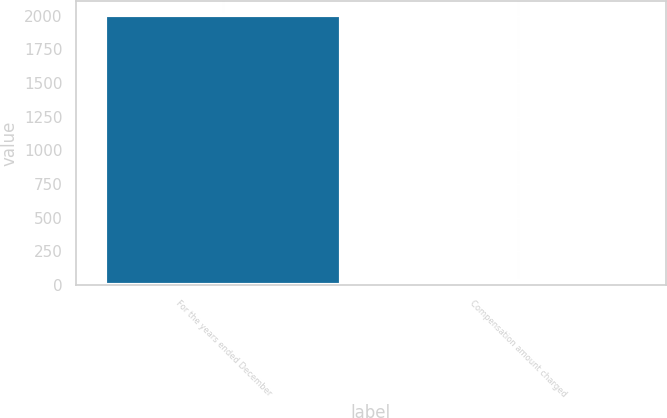Convert chart to OTSL. <chart><loc_0><loc_0><loc_500><loc_500><bar_chart><fcel>For the years ended December<fcel>Compensation amount charged<nl><fcel>2008<fcel>27.2<nl></chart> 